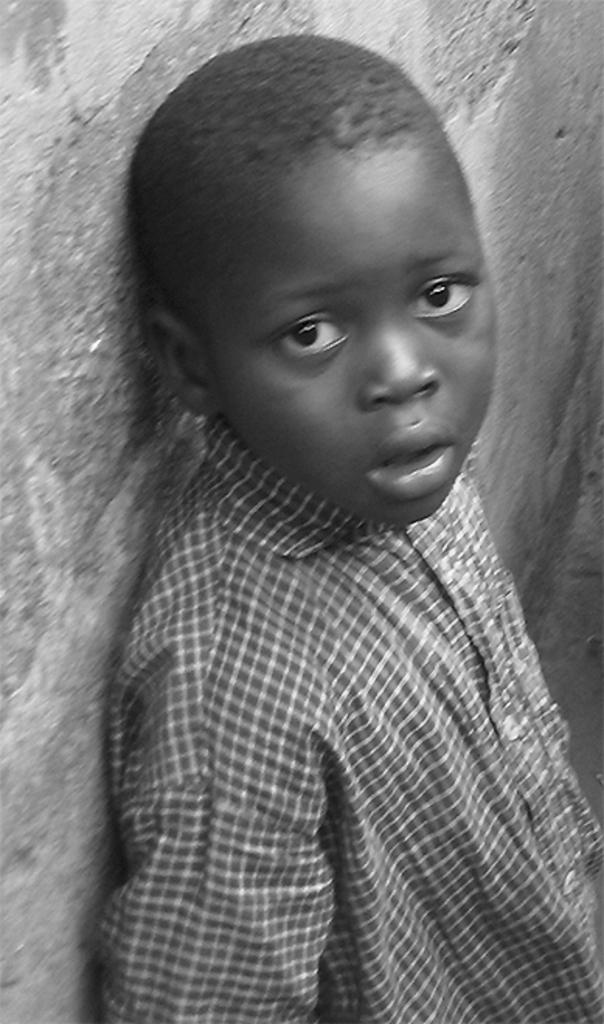What is the color scheme of the image? The image is black and white. Who or what is the main subject in the image? There is a boy in the image. Where is the boy located in the image? The boy is standing near a wall. What type of meal is the boy eating in the image? There is no meal present in the image, as it is a black and white image of a boy standing near a wall. 